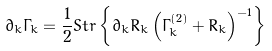Convert formula to latex. <formula><loc_0><loc_0><loc_500><loc_500>\partial _ { k } \Gamma _ { k } = \frac { 1 } { 2 } S t r \left \{ \partial _ { k } R _ { k } \left ( \Gamma ^ { ( 2 ) } _ { k } + R _ { k } \right ) ^ { - 1 } \right \}</formula> 